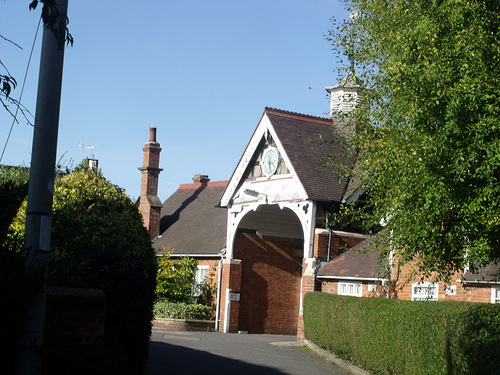<image>
Is there a house behind the grass? Yes. From this viewpoint, the house is positioned behind the grass, with the grass partially or fully occluding the house. 